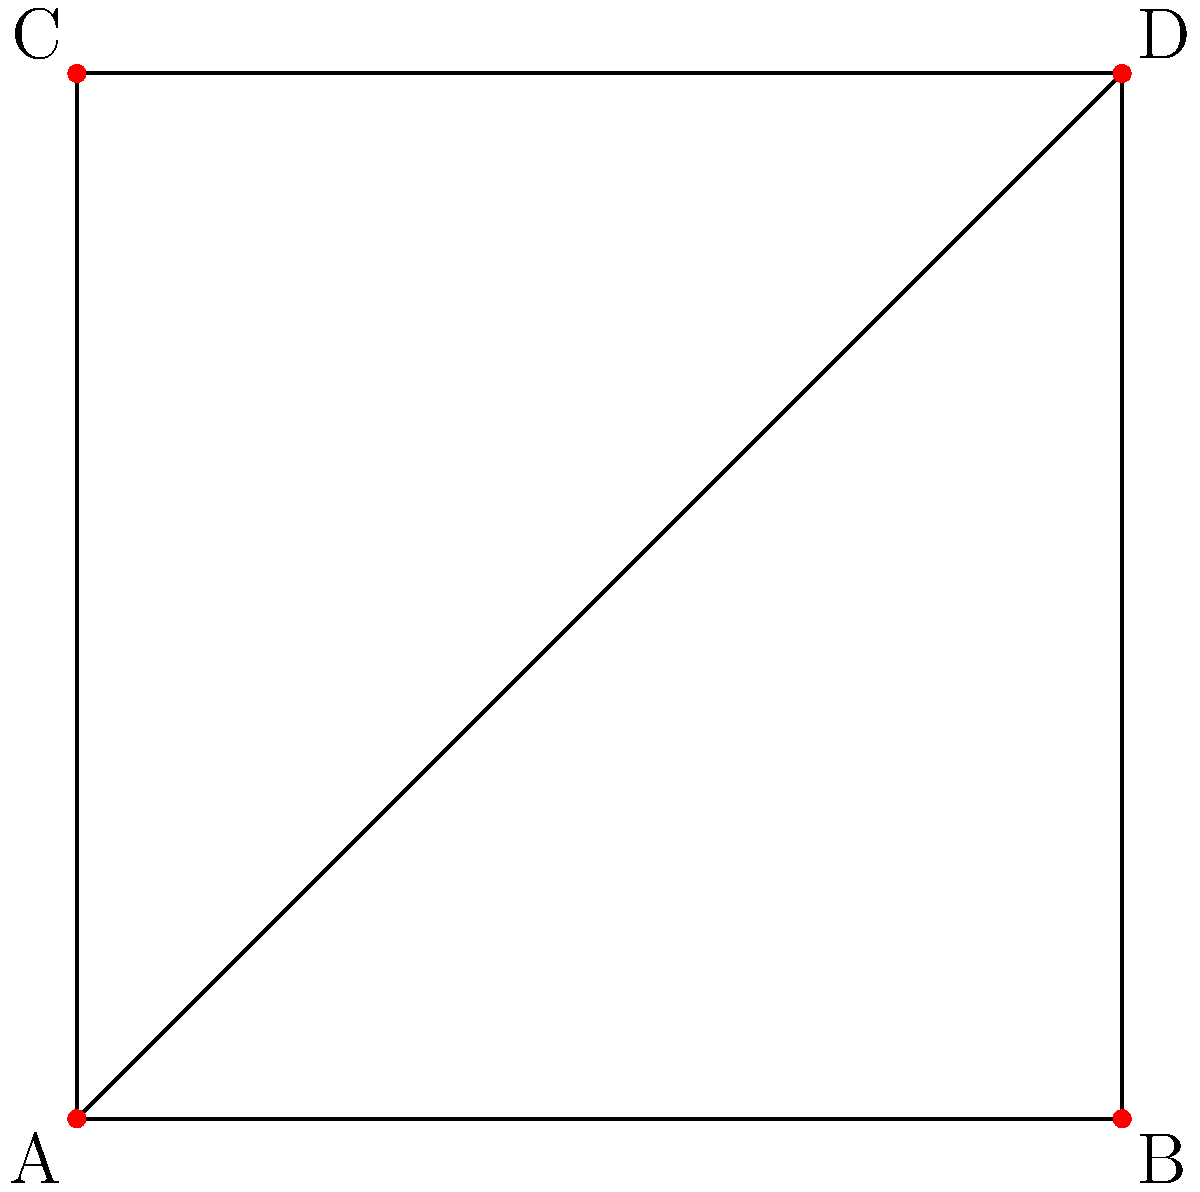At a music festival, four stages (A, B, C, and D) are connected by paths as shown in the diagram. Assuming each path represents a deformation retract, what is the fundamental group of this space? Express your answer using the standard notation for the fundamental group. To determine the fundamental group of this space, we'll follow these steps:

1) First, observe that the space is essentially a square with a diagonal. This is homotopy equivalent to a figure-eight shape, as we can continuously deform the square with diagonal into two loops meeting at a point.

2) The figure-eight shape is well-known in topology as the wedge sum of two circles, often denoted as $S^1 \vee S^1$.

3) The fundamental group of a wedge sum of circles is isomorphic to the free group on as many generators as there are circles. In this case, we have two circles.

4) The fundamental group of a single circle $S^1$ is isomorphic to the integers under addition, denoted as $\mathbb{Z}$.

5) For the wedge sum of two circles, we get the free group on two generators, which is typically denoted as $F_2$.

6) In the language of fundamental groups, this is written as $\pi_1(S^1 \vee S^1) \cong F_2$.

Therefore, the fundamental group of the space formed by the interconnected music festival stages is isomorphic to the free group on two generators.
Answer: $\pi_1 \cong F_2$ 